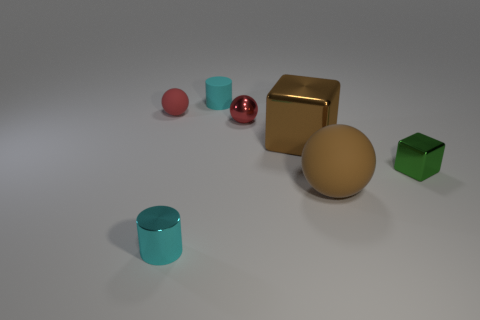The rubber ball that is the same color as the big metal thing is what size?
Ensure brevity in your answer.  Large. Is the number of matte objects in front of the brown ball less than the number of tiny rubber balls on the right side of the cyan rubber cylinder?
Keep it short and to the point. No. Is the number of small red rubber spheres that are to the left of the red rubber object less than the number of tiny purple metal things?
Provide a succinct answer. No. What is the material of the small cyan cylinder to the left of the small cyan object that is behind the brown shiny thing on the left side of the green block?
Provide a short and direct response. Metal. What number of objects are blocks that are behind the green block or tiny spheres to the left of the metallic cylinder?
Your answer should be very brief. 2. There is another red thing that is the same shape as the red metallic object; what material is it?
Ensure brevity in your answer.  Rubber. What number of matte things are either small cubes or small cyan cubes?
Give a very brief answer. 0. There is a cyan thing that is the same material as the large block; what is its shape?
Provide a short and direct response. Cylinder. How many tiny red matte things are the same shape as the big rubber object?
Your answer should be compact. 1. Do the large brown thing that is behind the big matte ball and the small matte thing in front of the tiny cyan rubber object have the same shape?
Your answer should be compact. No. 